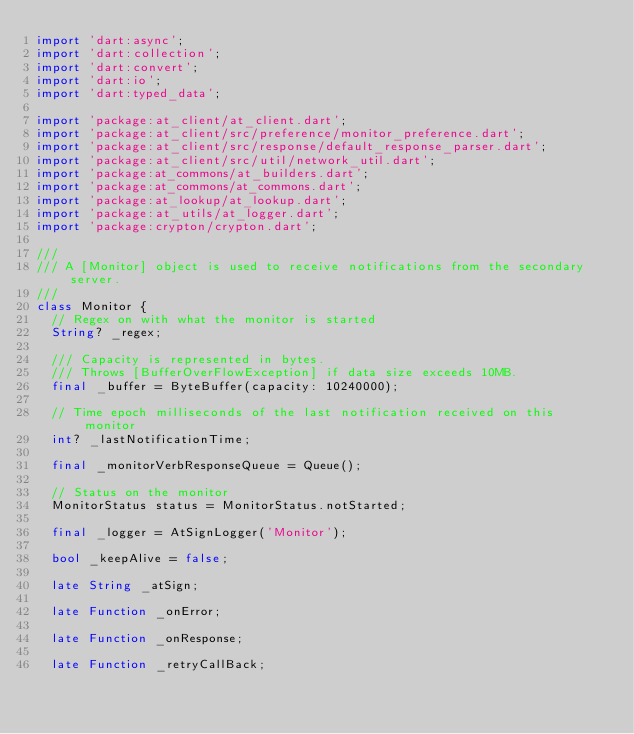Convert code to text. <code><loc_0><loc_0><loc_500><loc_500><_Dart_>import 'dart:async';
import 'dart:collection';
import 'dart:convert';
import 'dart:io';
import 'dart:typed_data';

import 'package:at_client/at_client.dart';
import 'package:at_client/src/preference/monitor_preference.dart';
import 'package:at_client/src/response/default_response_parser.dart';
import 'package:at_client/src/util/network_util.dart';
import 'package:at_commons/at_builders.dart';
import 'package:at_commons/at_commons.dart';
import 'package:at_lookup/at_lookup.dart';
import 'package:at_utils/at_logger.dart';
import 'package:crypton/crypton.dart';

///
/// A [Monitor] object is used to receive notifications from the secondary server.
///
class Monitor {
  // Regex on with what the monitor is started
  String? _regex;

  /// Capacity is represented in bytes.
  /// Throws [BufferOverFlowException] if data size exceeds 10MB.
  final _buffer = ByteBuffer(capacity: 10240000);

  // Time epoch milliseconds of the last notification received on this monitor
  int? _lastNotificationTime;

  final _monitorVerbResponseQueue = Queue();

  // Status on the monitor
  MonitorStatus status = MonitorStatus.notStarted;

  final _logger = AtSignLogger('Monitor');

  bool _keepAlive = false;

  late String _atSign;

  late Function _onError;

  late Function _onResponse;

  late Function _retryCallBack;
</code> 